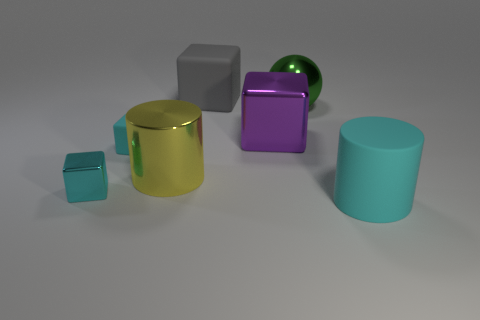Can you tell me about the color palette in this image? Certainly! The color palette includes teal, green, gold, purple, and gray, which provide a mix of both cool and warm tones. Do the colors of the objects have any consistent theme or coordination? There doesn't seem to be a strict color coordination or theme. The colors vary widely, suggesting no particular scheme was intended. How does the lighting affect the appearance of the objects? The lighting creates subtle shadows and highlights on the objects, emphasizing their shapes and the differences in their surfaces—matte versus shiny. 